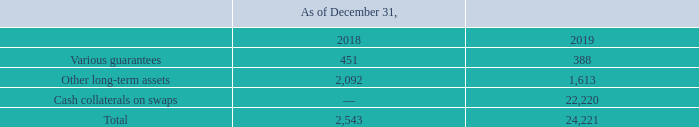GasLog Ltd. and its Subsidiaries
Notes to the consolidated financial statements (Continued)
For the years ended December 31, 2017, 2018 and 2019
(All amounts expressed in thousands of U.S. Dollars, except share and per share data)
10. Other Non-Current Assets
Other non-current assets consist of the following:
Cash collaterals on swaps represent cash deposited for the Group’s interest rate swaps being the difference between their fair value and an agreed threshold.
What does cash collaterals on swaps represent? Cash collaterals on swaps represent cash deposited for the group’s interest rate swaps being the difference between their fair value and an agreed threshold. In which year was the other non-current assets recorded for? 2019, 2018. What was the amount of cash collaterals on swaps in 2019?
Answer scale should be: thousand. 22,220. In which year was the other long-term assets higher? 2,092 > 1,613
Answer: 2018. What was the change in various guarantees from 2018 to 2019?
Answer scale should be: thousand. 388 - 451 
Answer: -63. What was the percentage change in total other non-current assets from 2018 to 2019?
Answer scale should be: percent. (24,221 - 2,543)/2,543 
Answer: 852.46. 